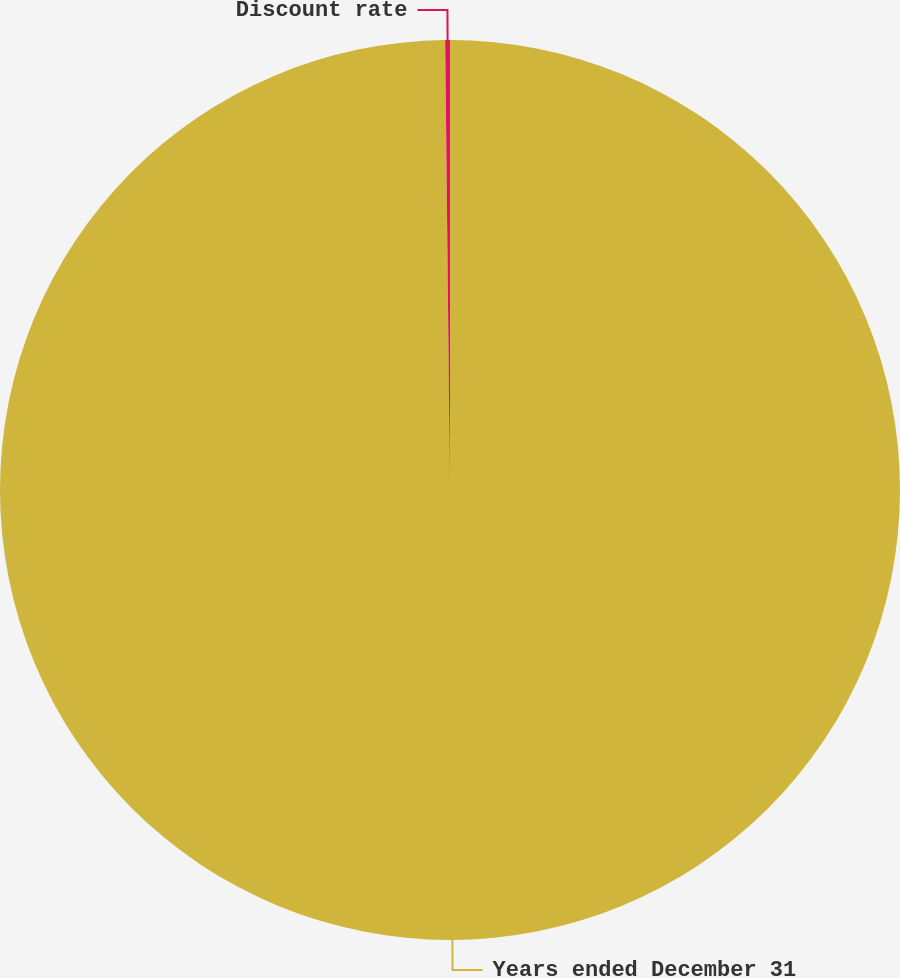Convert chart. <chart><loc_0><loc_0><loc_500><loc_500><pie_chart><fcel>Years ended December 31<fcel>Discount rate<nl><fcel>99.83%<fcel>0.17%<nl></chart> 